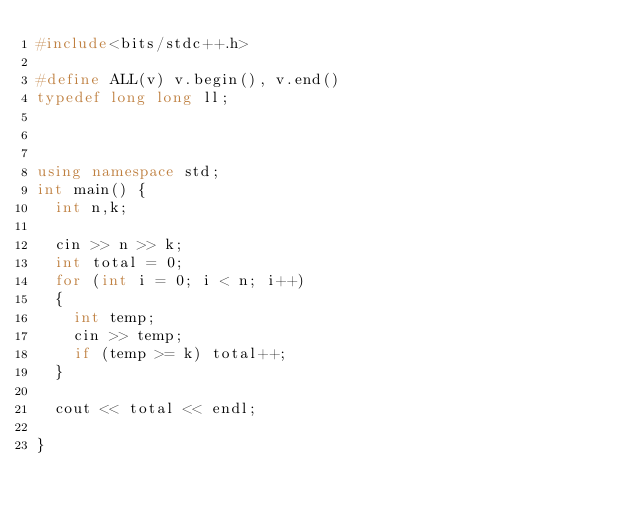Convert code to text. <code><loc_0><loc_0><loc_500><loc_500><_C++_>#include<bits/stdc++.h>

#define ALL(v) v.begin(), v.end()
typedef long long ll;



using namespace std;
int main() {
	int n,k;
	
	cin >> n >> k;
	int total = 0;
	for (int i = 0; i < n; i++)
	{
		int temp;
		cin >> temp;
		if (temp >= k) total++;
	}
	
	cout << total << endl;

}</code> 